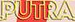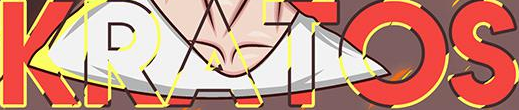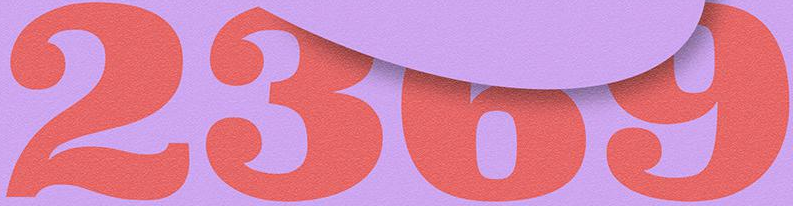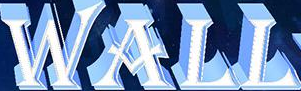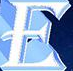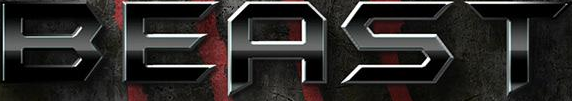What words are shown in these images in order, separated by a semicolon? PUTRA; KRATOS; 2369; WALL; E; BEAST 